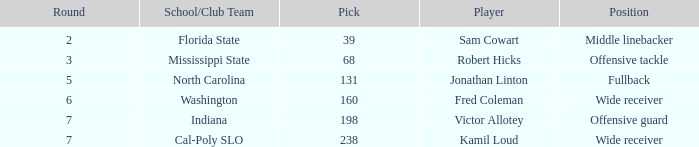Which School/Club Team has a Pick of 198? Indiana. 